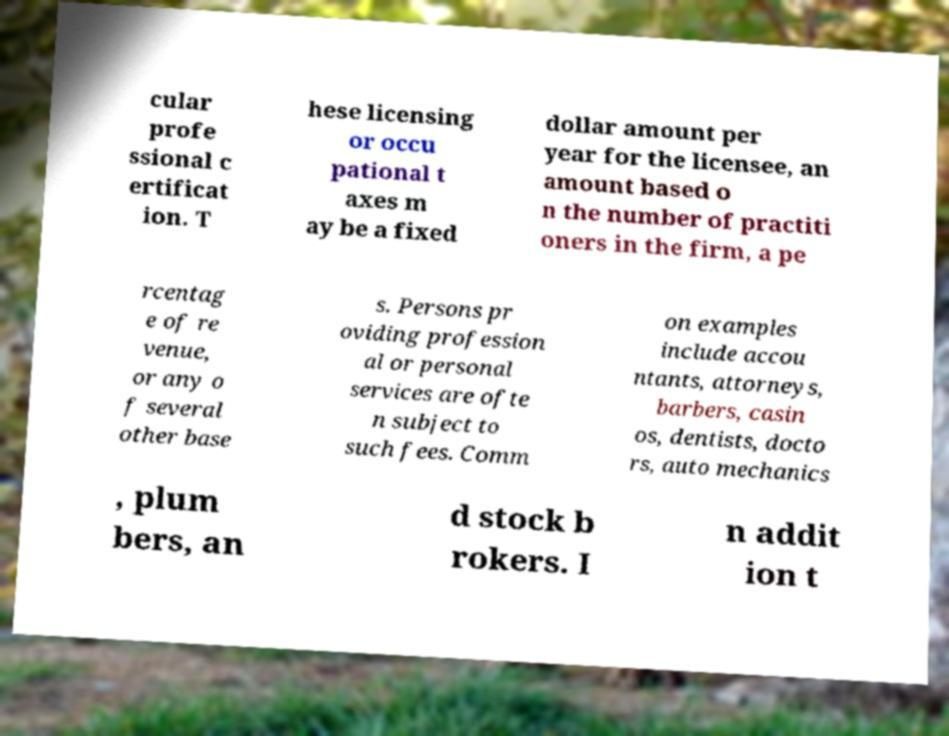What messages or text are displayed in this image? I need them in a readable, typed format. cular profe ssional c ertificat ion. T hese licensing or occu pational t axes m ay be a fixed dollar amount per year for the licensee, an amount based o n the number of practiti oners in the firm, a pe rcentag e of re venue, or any o f several other base s. Persons pr oviding profession al or personal services are ofte n subject to such fees. Comm on examples include accou ntants, attorneys, barbers, casin os, dentists, docto rs, auto mechanics , plum bers, an d stock b rokers. I n addit ion t 